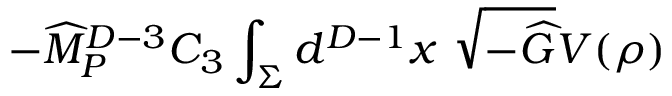Convert formula to latex. <formula><loc_0><loc_0><loc_500><loc_500>- { \widehat { M } } _ { P } ^ { D - 3 } C _ { 3 } \int _ { \Sigma } d ^ { D - 1 } x \sqrt { - { \widehat { G } } } V ( \rho )</formula> 